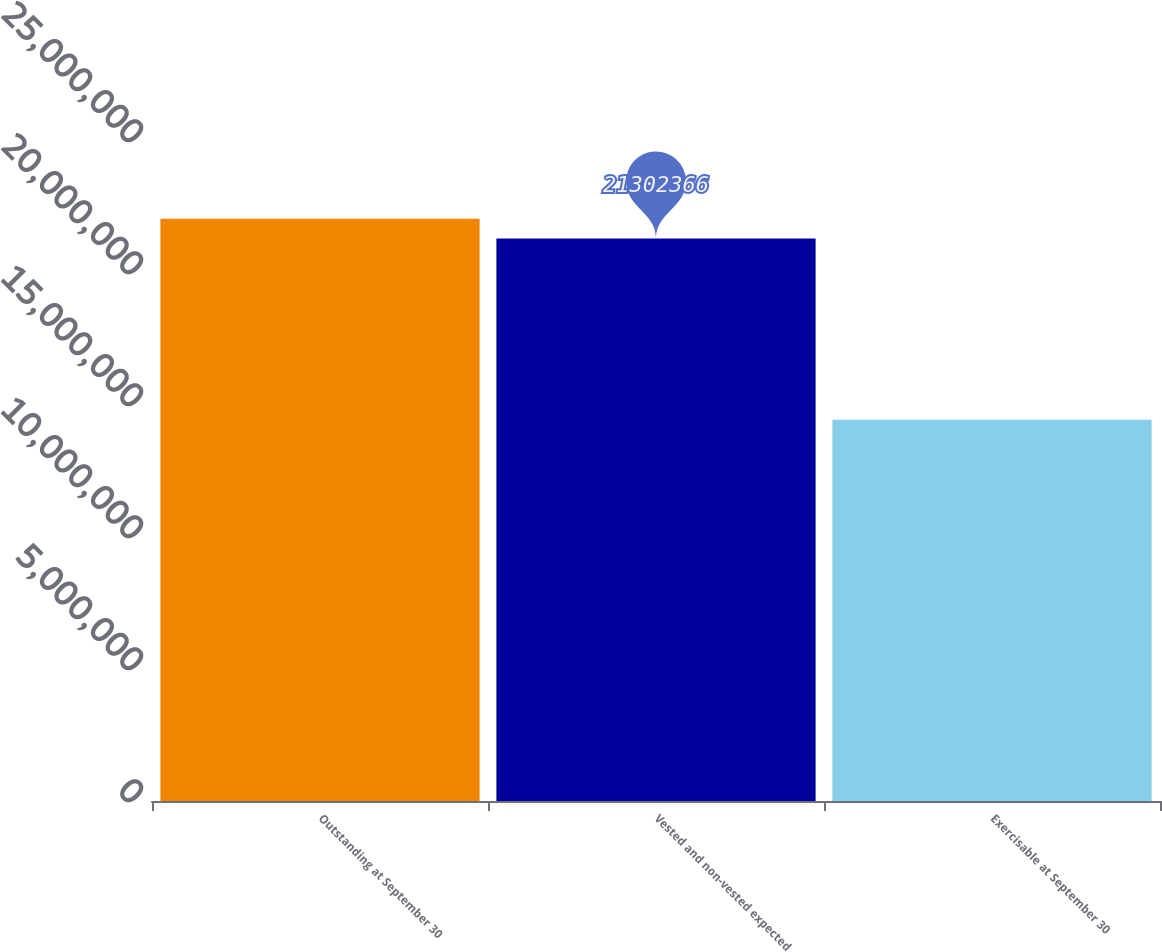<chart> <loc_0><loc_0><loc_500><loc_500><bar_chart><fcel>Outstanding at September 30<fcel>Vested and non-vested expected<fcel>Exercisable at September 30<nl><fcel>2.20507e+07<fcel>2.13024e+07<fcel>1.44372e+07<nl></chart> 